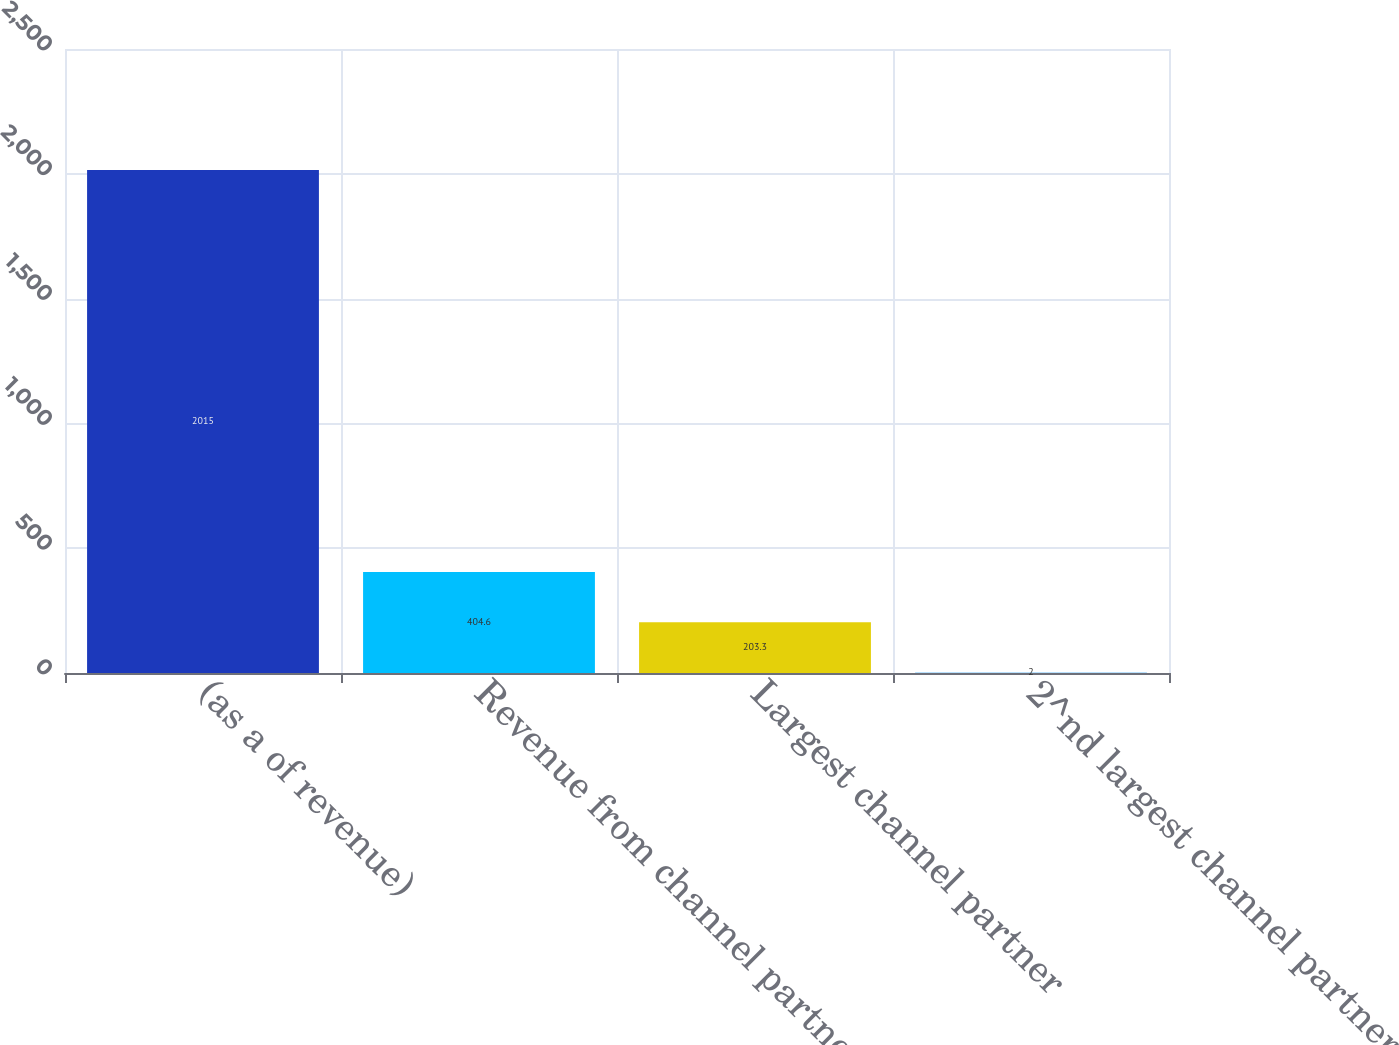Convert chart to OTSL. <chart><loc_0><loc_0><loc_500><loc_500><bar_chart><fcel>(as a of revenue)<fcel>Revenue from channel partners<fcel>Largest channel partner<fcel>2^nd largest channel partner<nl><fcel>2015<fcel>404.6<fcel>203.3<fcel>2<nl></chart> 